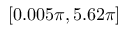Convert formula to latex. <formula><loc_0><loc_0><loc_500><loc_500>[ 0 . 0 0 5 \pi , 5 . 6 2 \pi ]</formula> 